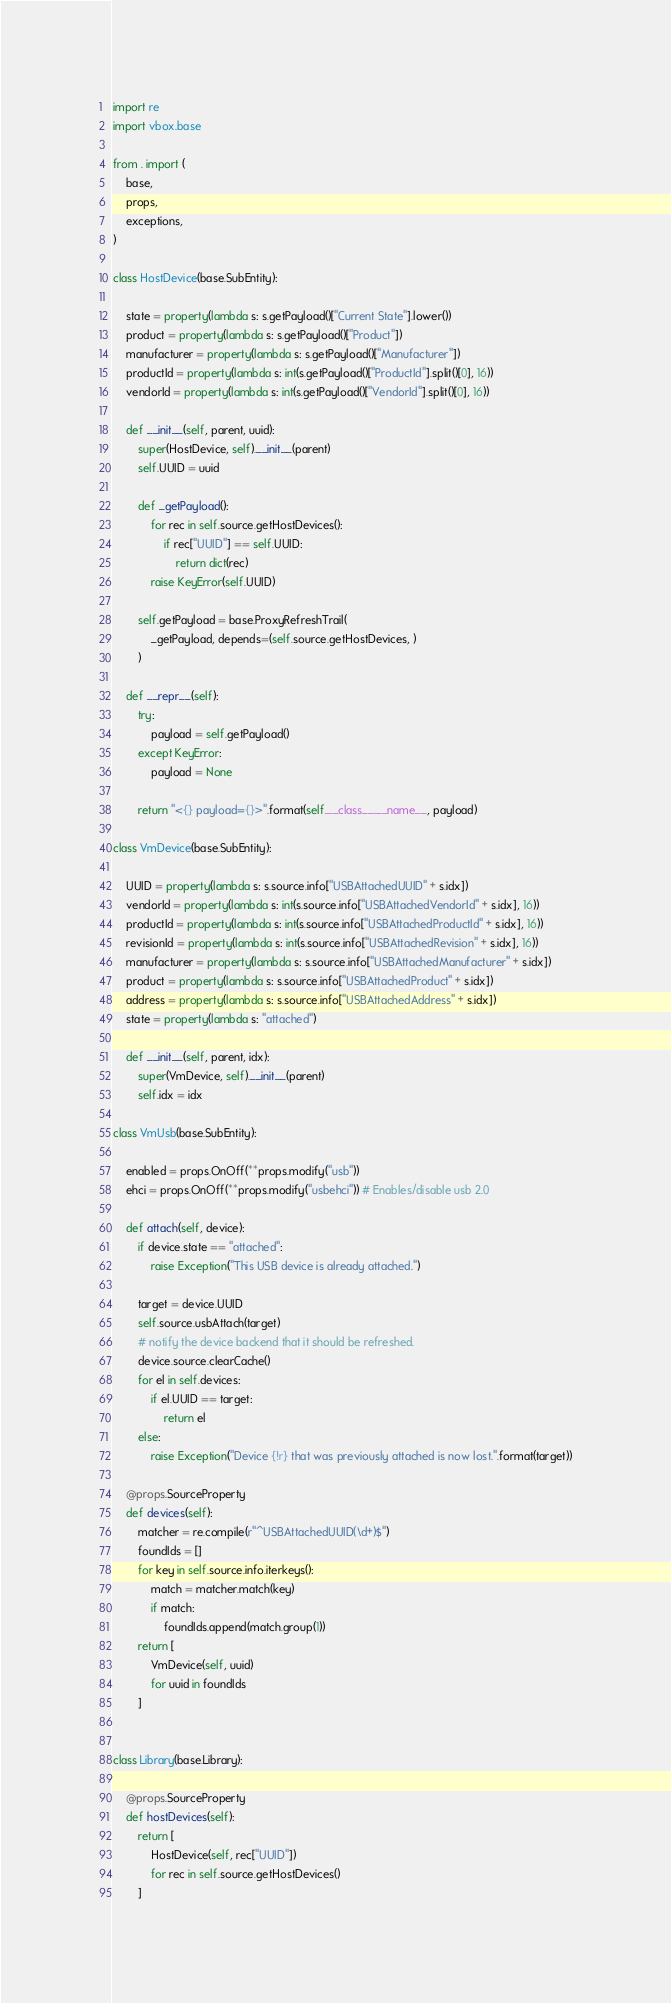Convert code to text. <code><loc_0><loc_0><loc_500><loc_500><_Python_>import re
import vbox.base

from . import (
    base,
    props,
    exceptions,
)

class HostDevice(base.SubEntity):

    state = property(lambda s: s.getPayload()["Current State"].lower())
    product = property(lambda s: s.getPayload()["Product"])
    manufacturer = property(lambda s: s.getPayload()["Manufacturer"])
    productId = property(lambda s: int(s.getPayload()["ProductId"].split()[0], 16))
    vendorId = property(lambda s: int(s.getPayload()["VendorId"].split()[0], 16))

    def __init__(self, parent, uuid):
        super(HostDevice, self).__init__(parent)
        self.UUID = uuid

        def _getPayload():
            for rec in self.source.getHostDevices():
                if rec["UUID"] == self.UUID:
                    return dict(rec)
            raise KeyError(self.UUID)

        self.getPayload = base.ProxyRefreshTrail(
            _getPayload, depends=(self.source.getHostDevices, )
        )

    def __repr__(self):
        try:
            payload = self.getPayload()
        except KeyError:
            payload = None

        return "<{} payload={}>".format(self.__class__.__name__, payload)

class VmDevice(base.SubEntity):

    UUID = property(lambda s: s.source.info["USBAttachedUUID" + s.idx])
    vendorId = property(lambda s: int(s.source.info["USBAttachedVendorId" + s.idx], 16))
    productId = property(lambda s: int(s.source.info["USBAttachedProductId" + s.idx], 16))
    revisionId = property(lambda s: int(s.source.info["USBAttachedRevision" + s.idx], 16))
    manufacturer = property(lambda s: s.source.info["USBAttachedManufacturer" + s.idx])
    product = property(lambda s: s.source.info["USBAttachedProduct" + s.idx])
    address = property(lambda s: s.source.info["USBAttachedAddress" + s.idx])
    state = property(lambda s: "attached")

    def __init__(self, parent, idx):
        super(VmDevice, self).__init__(parent)
        self.idx = idx

class VmUsb(base.SubEntity):

    enabled = props.OnOff(**props.modify("usb"))
    ehci = props.OnOff(**props.modify("usbehci")) # Enables/disable usb 2.0

    def attach(self, device):
        if device.state == "attached":
            raise Exception("This USB device is already attached.")

        target = device.UUID
        self.source.usbAttach(target)
        # notify the device backend that it should be refreshed.
        device.source.clearCache()
        for el in self.devices:
            if el.UUID == target:
                return el
        else:
            raise Exception("Device {!r} that was previously attached is now lost.".format(target))

    @props.SourceProperty
    def devices(self):
        matcher = re.compile(r"^USBAttachedUUID(\d+)$")
        foundIds = []
        for key in self.source.info.iterkeys():
            match = matcher.match(key)
            if match:
                foundIds.append(match.group(1))
        return [
            VmDevice(self, uuid)
            for uuid in foundIds
        ]


class Library(base.Library):

    @props.SourceProperty
    def hostDevices(self):
        return [
            HostDevice(self, rec["UUID"])
            for rec in self.source.getHostDevices()
        ]</code> 